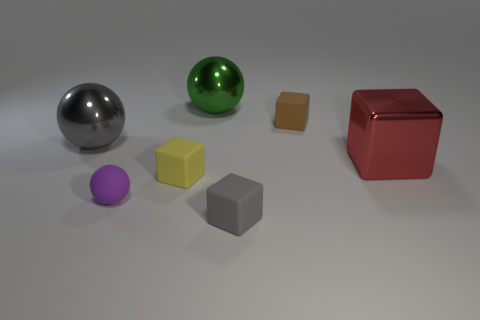Add 3 shiny cubes. How many objects exist? 10 Subtract all balls. How many objects are left? 4 Subtract all brown blocks. Subtract all purple spheres. How many objects are left? 5 Add 2 small brown matte blocks. How many small brown matte blocks are left? 3 Add 4 matte things. How many matte things exist? 8 Subtract 0 red cylinders. How many objects are left? 7 